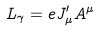Convert formula to latex. <formula><loc_0><loc_0><loc_500><loc_500>L _ { \gamma } = e J ^ { \prime } _ { \mu } A ^ { \mu }</formula> 